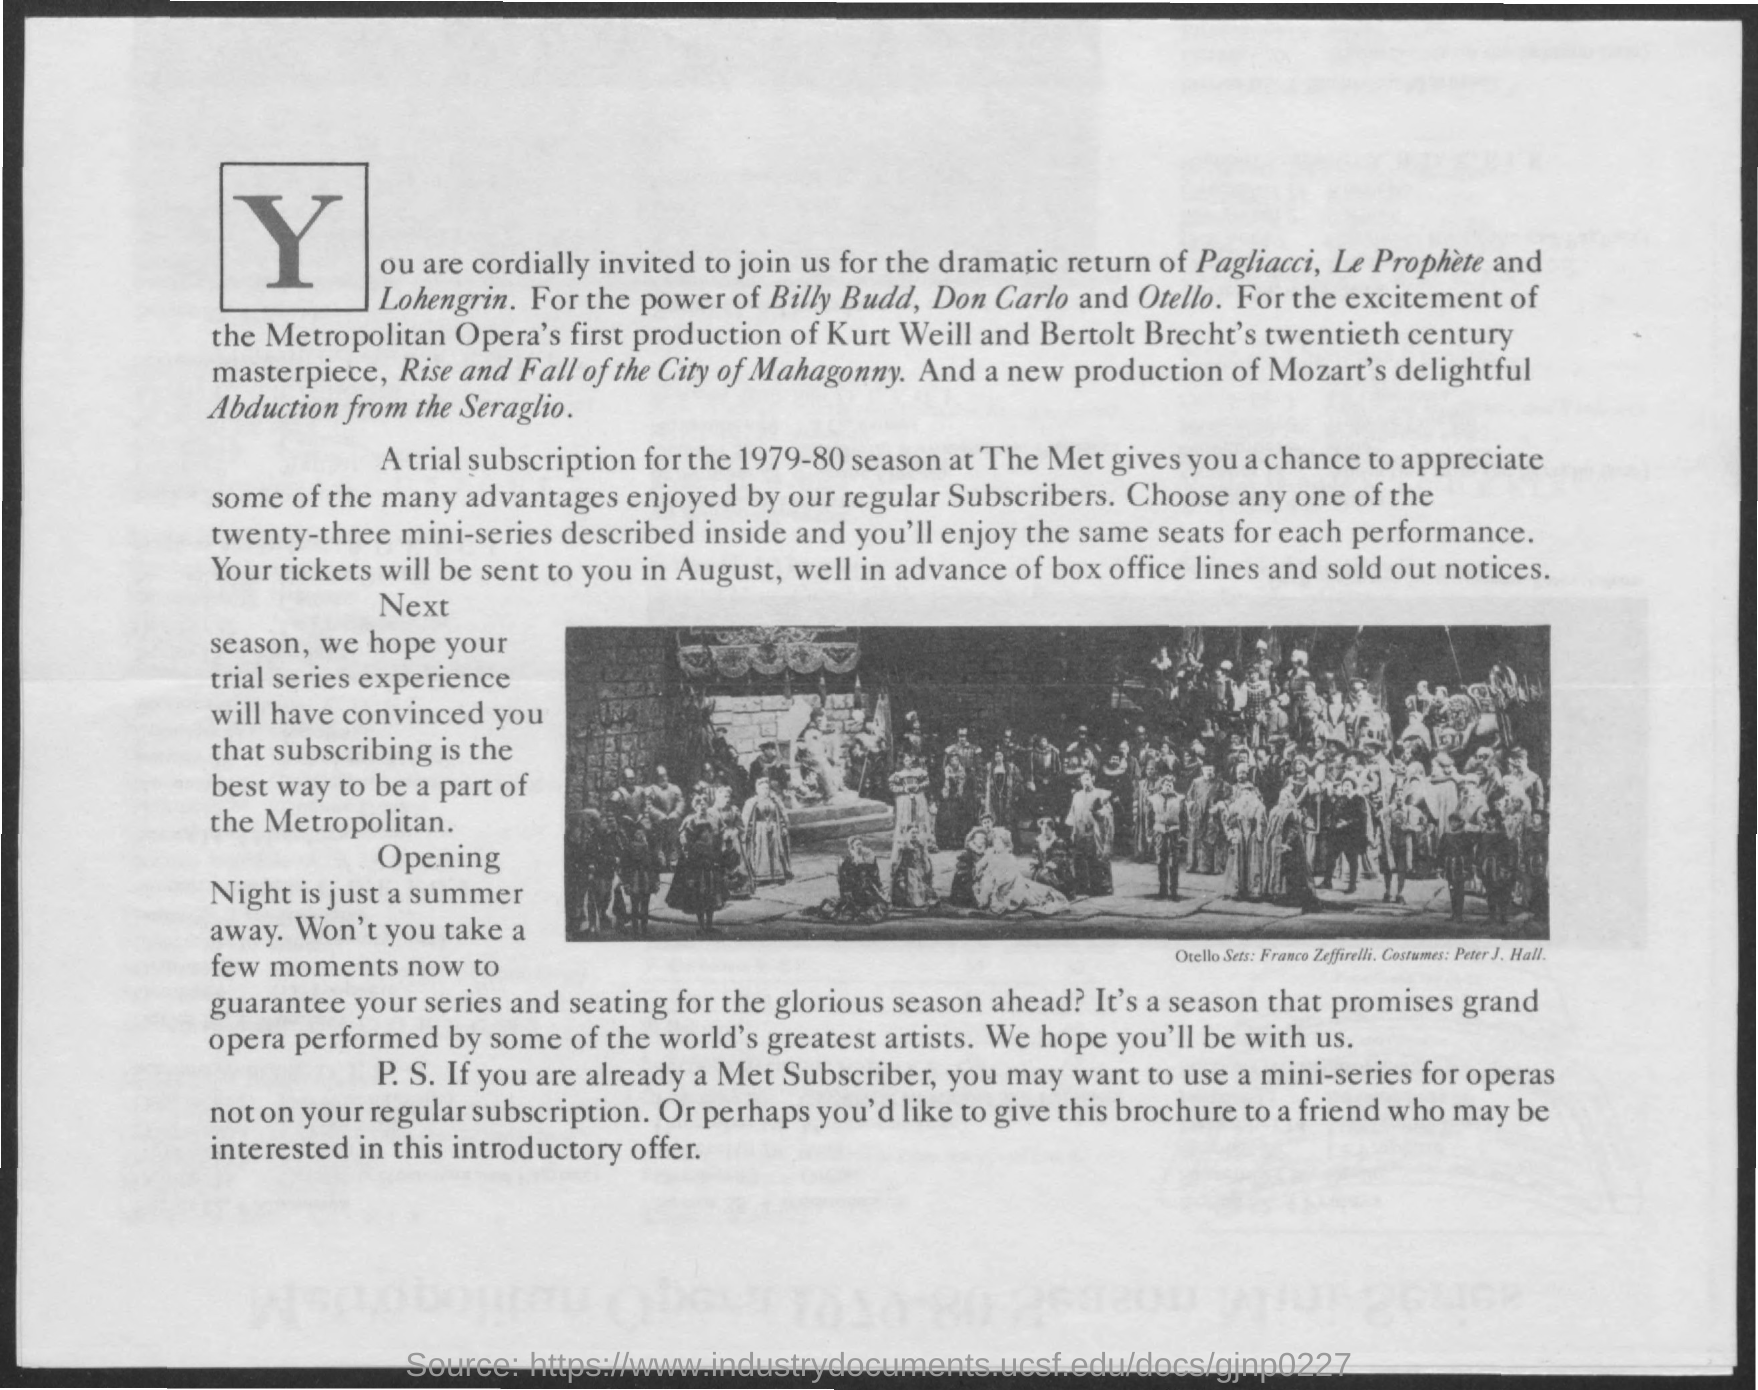Which 'letter' is shown in large fonts in the beginning of the document?
Your answer should be compact. Y. For which season,a trail subscription was done at The Met?
Keep it short and to the point. 1979-80. In which month,the tickets will be sent in advance of box office lines and sold out notices?
Provide a short and direct response. August. What was the facility given to Met subscribers in addition, not on their regular subscription?
Ensure brevity in your answer.  To use a mini-series for operas. Mention the new production of Mozart's delightful which is written in itallics?
Your answer should be very brief. Abduction from the seraglio. What was just a summer away ?
Keep it short and to the point. Opening night. 